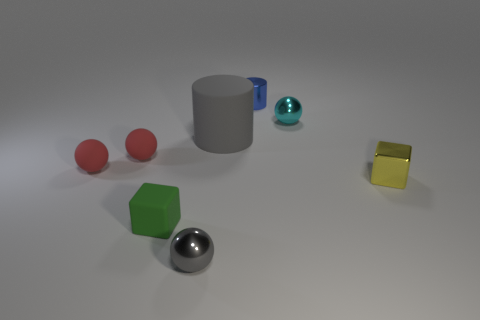Are there an equal number of cyan things that are right of the yellow cube and tiny red matte spheres?
Your response must be concise. No. Is there a rubber thing that is behind the metal sphere that is to the right of the small gray metal object?
Provide a short and direct response. No. What is the size of the object that is right of the ball that is to the right of the tiny shiny object behind the cyan shiny sphere?
Your answer should be compact. Small. There is a small cube in front of the small metal thing that is to the right of the cyan metal sphere; what is its material?
Your answer should be compact. Rubber. Is there another large rubber object of the same shape as the green object?
Provide a succinct answer. No. What shape is the green object?
Your answer should be very brief. Cube. There is a cube to the left of the big gray matte cylinder behind the yellow shiny cube that is to the right of the gray shiny object; what is it made of?
Your answer should be very brief. Rubber. Is the number of tiny gray objects that are to the right of the small blue cylinder greater than the number of small yellow blocks?
Offer a terse response. No. What material is the block that is the same size as the yellow shiny object?
Provide a succinct answer. Rubber. Is there a red matte sphere that has the same size as the green block?
Your answer should be very brief. Yes. 